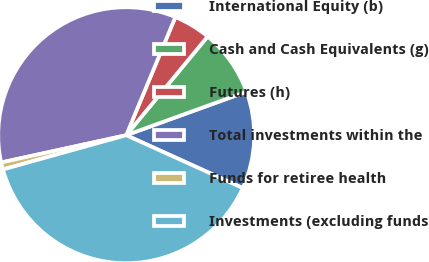<chart> <loc_0><loc_0><loc_500><loc_500><pie_chart><fcel>International Equity (b)<fcel>Cash and Cash Equivalents (g)<fcel>Futures (h)<fcel>Total investments within the<fcel>Funds for retiree health<fcel>Investments (excluding funds<nl><fcel>12.3%<fcel>8.5%<fcel>4.7%<fcel>34.69%<fcel>0.9%<fcel>38.91%<nl></chart> 